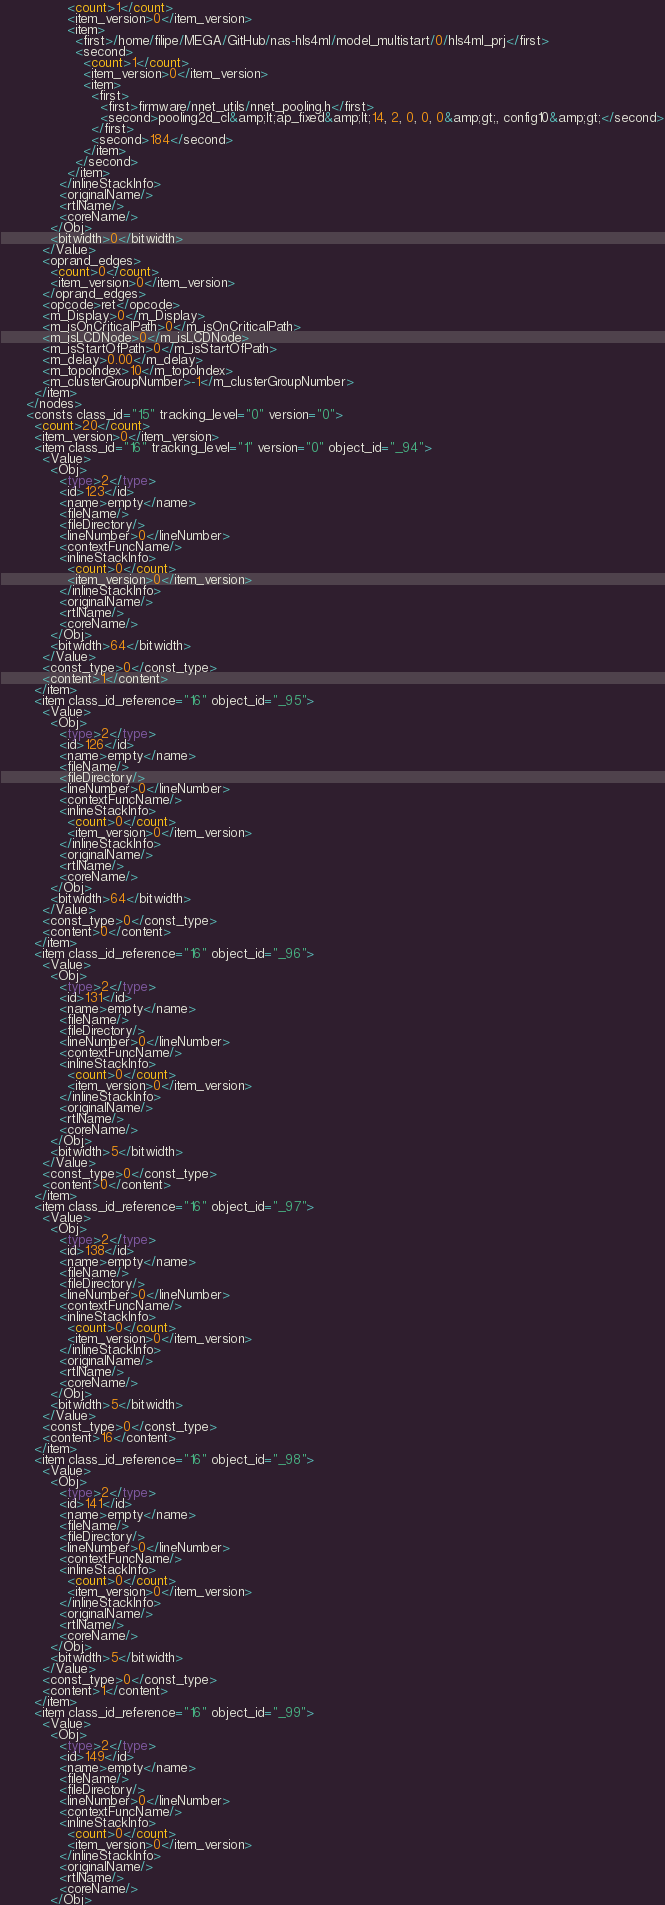<code> <loc_0><loc_0><loc_500><loc_500><_Ada_>                <count>1</count>
                <item_version>0</item_version>
                <item>
                  <first>/home/filipe/MEGA/GitHub/nas-hls4ml/model_multistart/0/hls4ml_prj</first>
                  <second>
                    <count>1</count>
                    <item_version>0</item_version>
                    <item>
                      <first>
                        <first>firmware/nnet_utils/nnet_pooling.h</first>
                        <second>pooling2d_cl&amp;lt;ap_fixed&amp;lt;14, 2, 0, 0, 0&amp;gt;, config10&amp;gt;</second>
                      </first>
                      <second>184</second>
                    </item>
                  </second>
                </item>
              </inlineStackInfo>
              <originalName/>
              <rtlName/>
              <coreName/>
            </Obj>
            <bitwidth>0</bitwidth>
          </Value>
          <oprand_edges>
            <count>0</count>
            <item_version>0</item_version>
          </oprand_edges>
          <opcode>ret</opcode>
          <m_Display>0</m_Display>
          <m_isOnCriticalPath>0</m_isOnCriticalPath>
          <m_isLCDNode>0</m_isLCDNode>
          <m_isStartOfPath>0</m_isStartOfPath>
          <m_delay>0.00</m_delay>
          <m_topoIndex>10</m_topoIndex>
          <m_clusterGroupNumber>-1</m_clusterGroupNumber>
        </item>
      </nodes>
      <consts class_id="15" tracking_level="0" version="0">
        <count>20</count>
        <item_version>0</item_version>
        <item class_id="16" tracking_level="1" version="0" object_id="_94">
          <Value>
            <Obj>
              <type>2</type>
              <id>123</id>
              <name>empty</name>
              <fileName/>
              <fileDirectory/>
              <lineNumber>0</lineNumber>
              <contextFuncName/>
              <inlineStackInfo>
                <count>0</count>
                <item_version>0</item_version>
              </inlineStackInfo>
              <originalName/>
              <rtlName/>
              <coreName/>
            </Obj>
            <bitwidth>64</bitwidth>
          </Value>
          <const_type>0</const_type>
          <content>1</content>
        </item>
        <item class_id_reference="16" object_id="_95">
          <Value>
            <Obj>
              <type>2</type>
              <id>126</id>
              <name>empty</name>
              <fileName/>
              <fileDirectory/>
              <lineNumber>0</lineNumber>
              <contextFuncName/>
              <inlineStackInfo>
                <count>0</count>
                <item_version>0</item_version>
              </inlineStackInfo>
              <originalName/>
              <rtlName/>
              <coreName/>
            </Obj>
            <bitwidth>64</bitwidth>
          </Value>
          <const_type>0</const_type>
          <content>0</content>
        </item>
        <item class_id_reference="16" object_id="_96">
          <Value>
            <Obj>
              <type>2</type>
              <id>131</id>
              <name>empty</name>
              <fileName/>
              <fileDirectory/>
              <lineNumber>0</lineNumber>
              <contextFuncName/>
              <inlineStackInfo>
                <count>0</count>
                <item_version>0</item_version>
              </inlineStackInfo>
              <originalName/>
              <rtlName/>
              <coreName/>
            </Obj>
            <bitwidth>5</bitwidth>
          </Value>
          <const_type>0</const_type>
          <content>0</content>
        </item>
        <item class_id_reference="16" object_id="_97">
          <Value>
            <Obj>
              <type>2</type>
              <id>138</id>
              <name>empty</name>
              <fileName/>
              <fileDirectory/>
              <lineNumber>0</lineNumber>
              <contextFuncName/>
              <inlineStackInfo>
                <count>0</count>
                <item_version>0</item_version>
              </inlineStackInfo>
              <originalName/>
              <rtlName/>
              <coreName/>
            </Obj>
            <bitwidth>5</bitwidth>
          </Value>
          <const_type>0</const_type>
          <content>16</content>
        </item>
        <item class_id_reference="16" object_id="_98">
          <Value>
            <Obj>
              <type>2</type>
              <id>141</id>
              <name>empty</name>
              <fileName/>
              <fileDirectory/>
              <lineNumber>0</lineNumber>
              <contextFuncName/>
              <inlineStackInfo>
                <count>0</count>
                <item_version>0</item_version>
              </inlineStackInfo>
              <originalName/>
              <rtlName/>
              <coreName/>
            </Obj>
            <bitwidth>5</bitwidth>
          </Value>
          <const_type>0</const_type>
          <content>1</content>
        </item>
        <item class_id_reference="16" object_id="_99">
          <Value>
            <Obj>
              <type>2</type>
              <id>149</id>
              <name>empty</name>
              <fileName/>
              <fileDirectory/>
              <lineNumber>0</lineNumber>
              <contextFuncName/>
              <inlineStackInfo>
                <count>0</count>
                <item_version>0</item_version>
              </inlineStackInfo>
              <originalName/>
              <rtlName/>
              <coreName/>
            </Obj></code> 